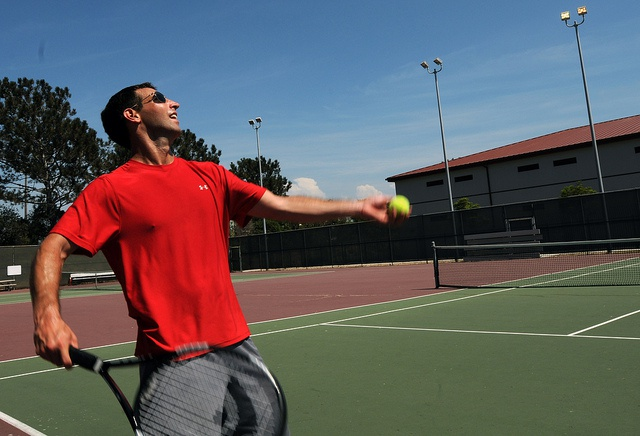Describe the objects in this image and their specific colors. I can see people in blue, red, black, gray, and brown tones, tennis racket in blue, gray, and black tones, sports ball in blue, khaki, and olive tones, and bench in blue, black, tan, and gray tones in this image. 